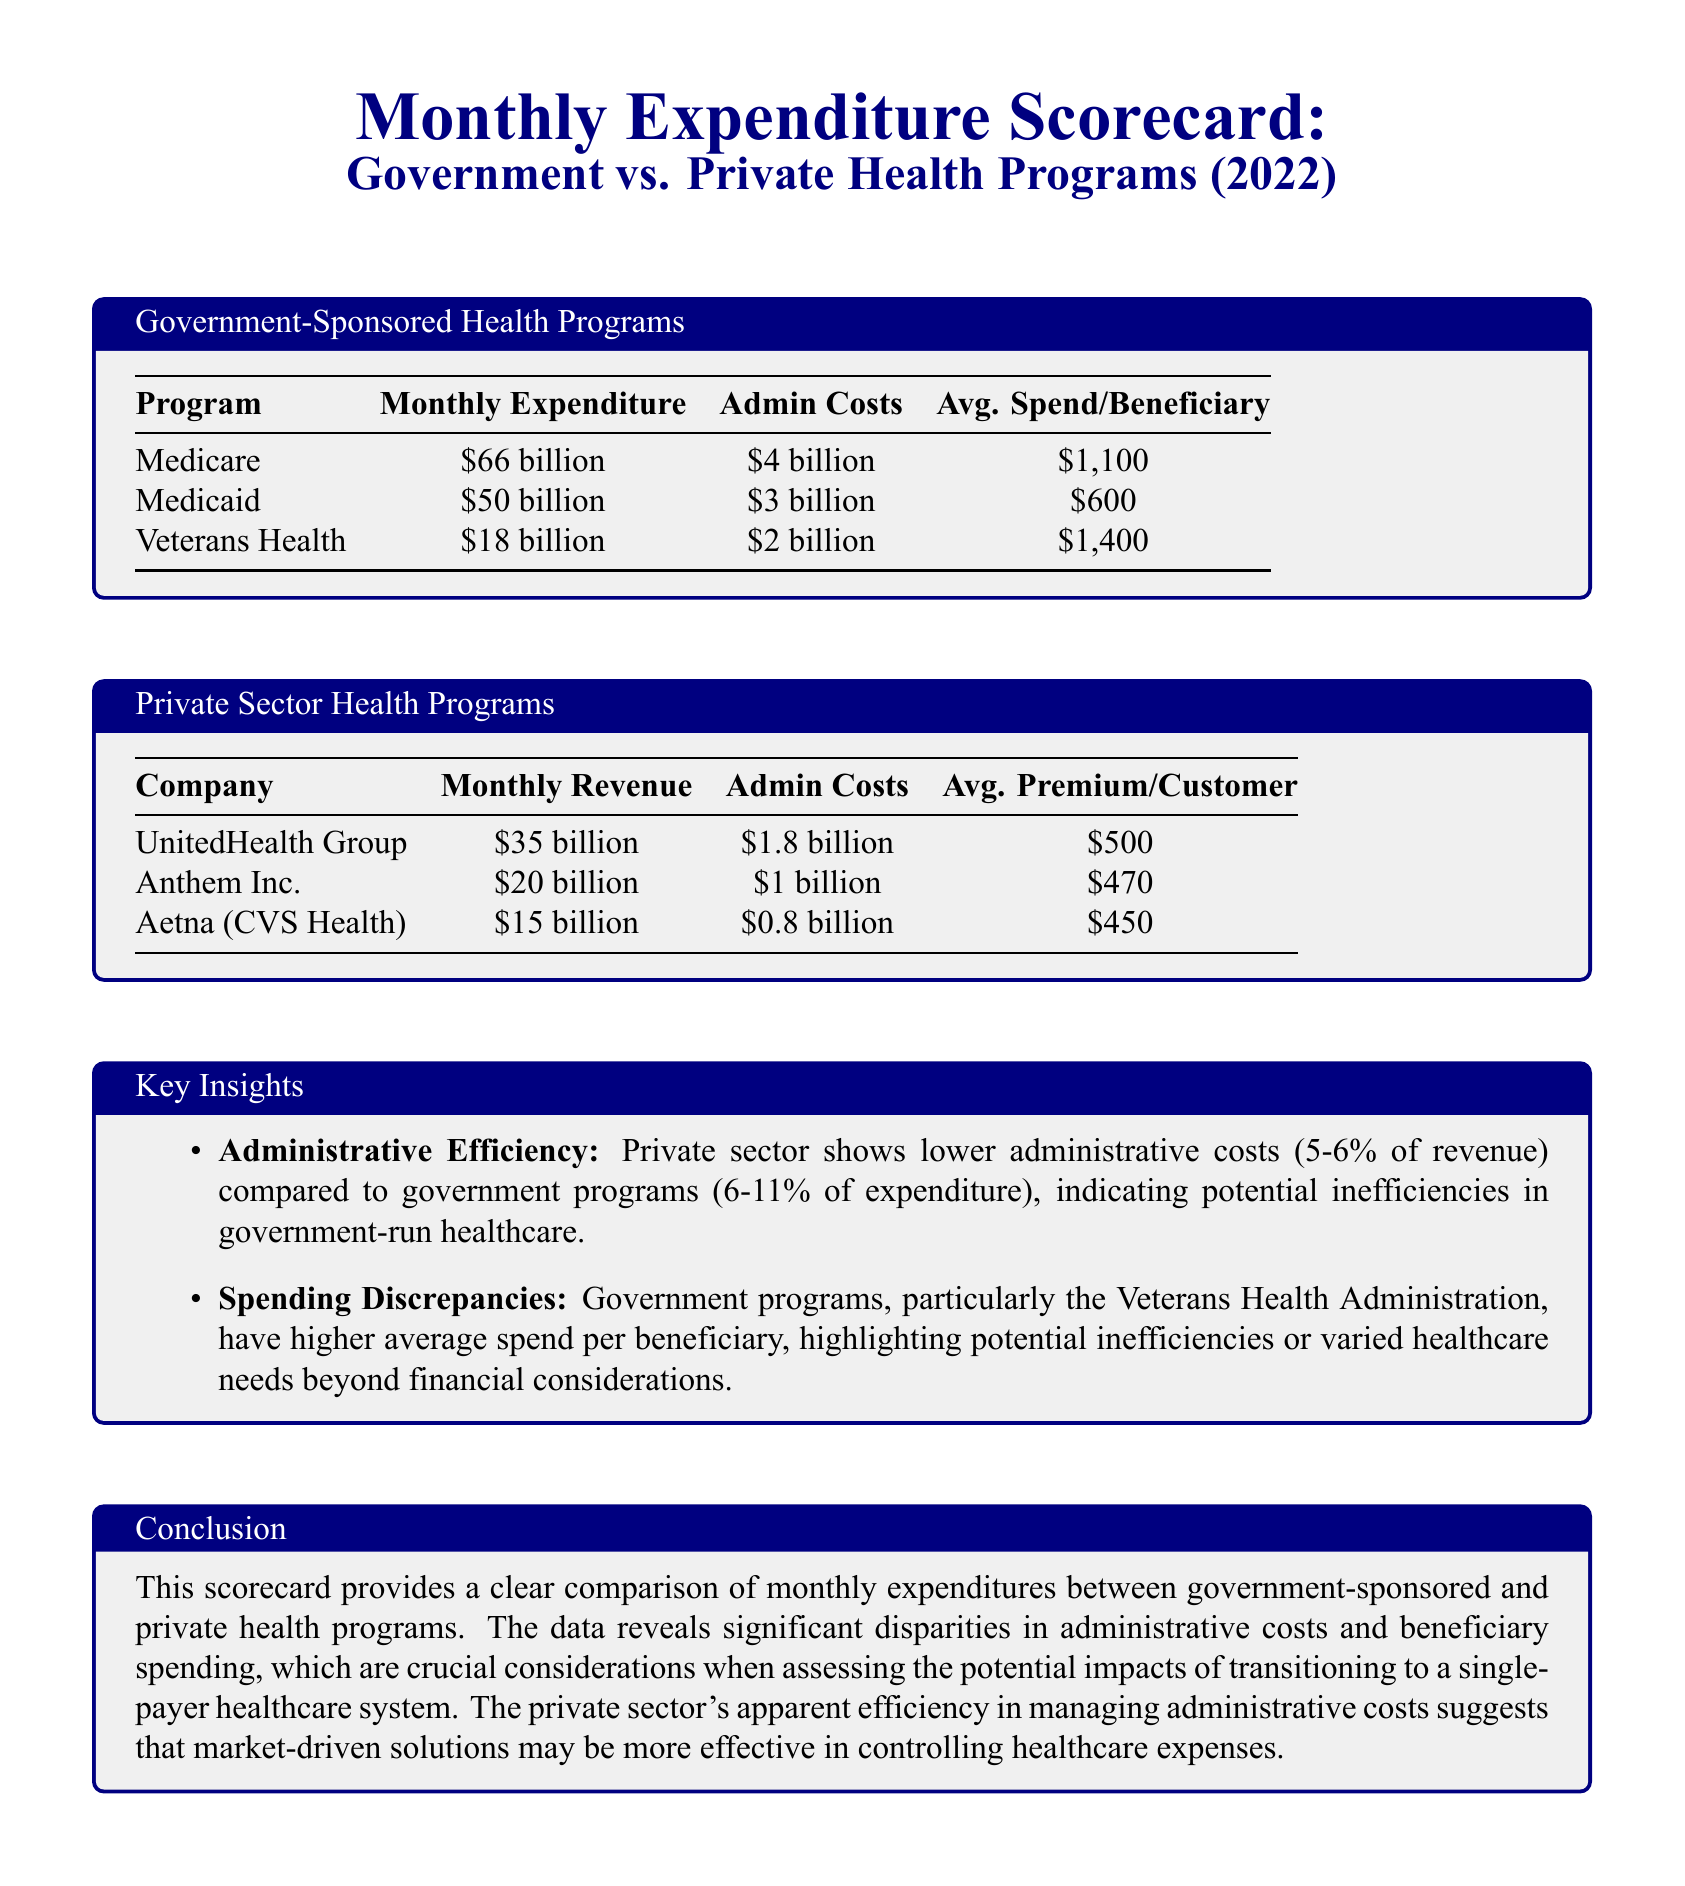What is the monthly expenditure for Medicare? The document states that the monthly expenditure for Medicare is $66 billion.
Answer: $66 billion What are the administrative costs for Medicaid? The document lists the administrative costs for Medicaid as $3 billion.
Answer: $3 billion Which private sector company has the highest monthly revenue? According to the document, UnitedHealth Group has the highest monthly revenue at $35 billion.
Answer: UnitedHealth Group What is the average premium per customer for Aetna? The average premium per customer for Aetna (CVS Health) as mentioned in the document is $450.
Answer: $450 What is the percentage range of administrative costs for private sector health programs? The document specifies that administrative costs for private sector programs range from 5-6% of revenue.
Answer: 5-6% How much more is the average spend per beneficiary in the Veterans Health program compared to Medicaid? The average spend per beneficiary in Veterans Health is $1,400, while in Medicaid it is $600, leading to a difference of $800.
Answer: $800 What is the total monthly expenditure for all government-sponsored health programs? The total monthly expenditure for Medicare, Medicaid, and Veterans Health combined is $66 billion + $50 billion + $18 billion = $134 billion.
Answer: $134 billion What key insight is provided regarding administrative efficiency? The document notes that the private sector shows lower administrative costs compared to government programs.
Answer: Lower administrative costs 